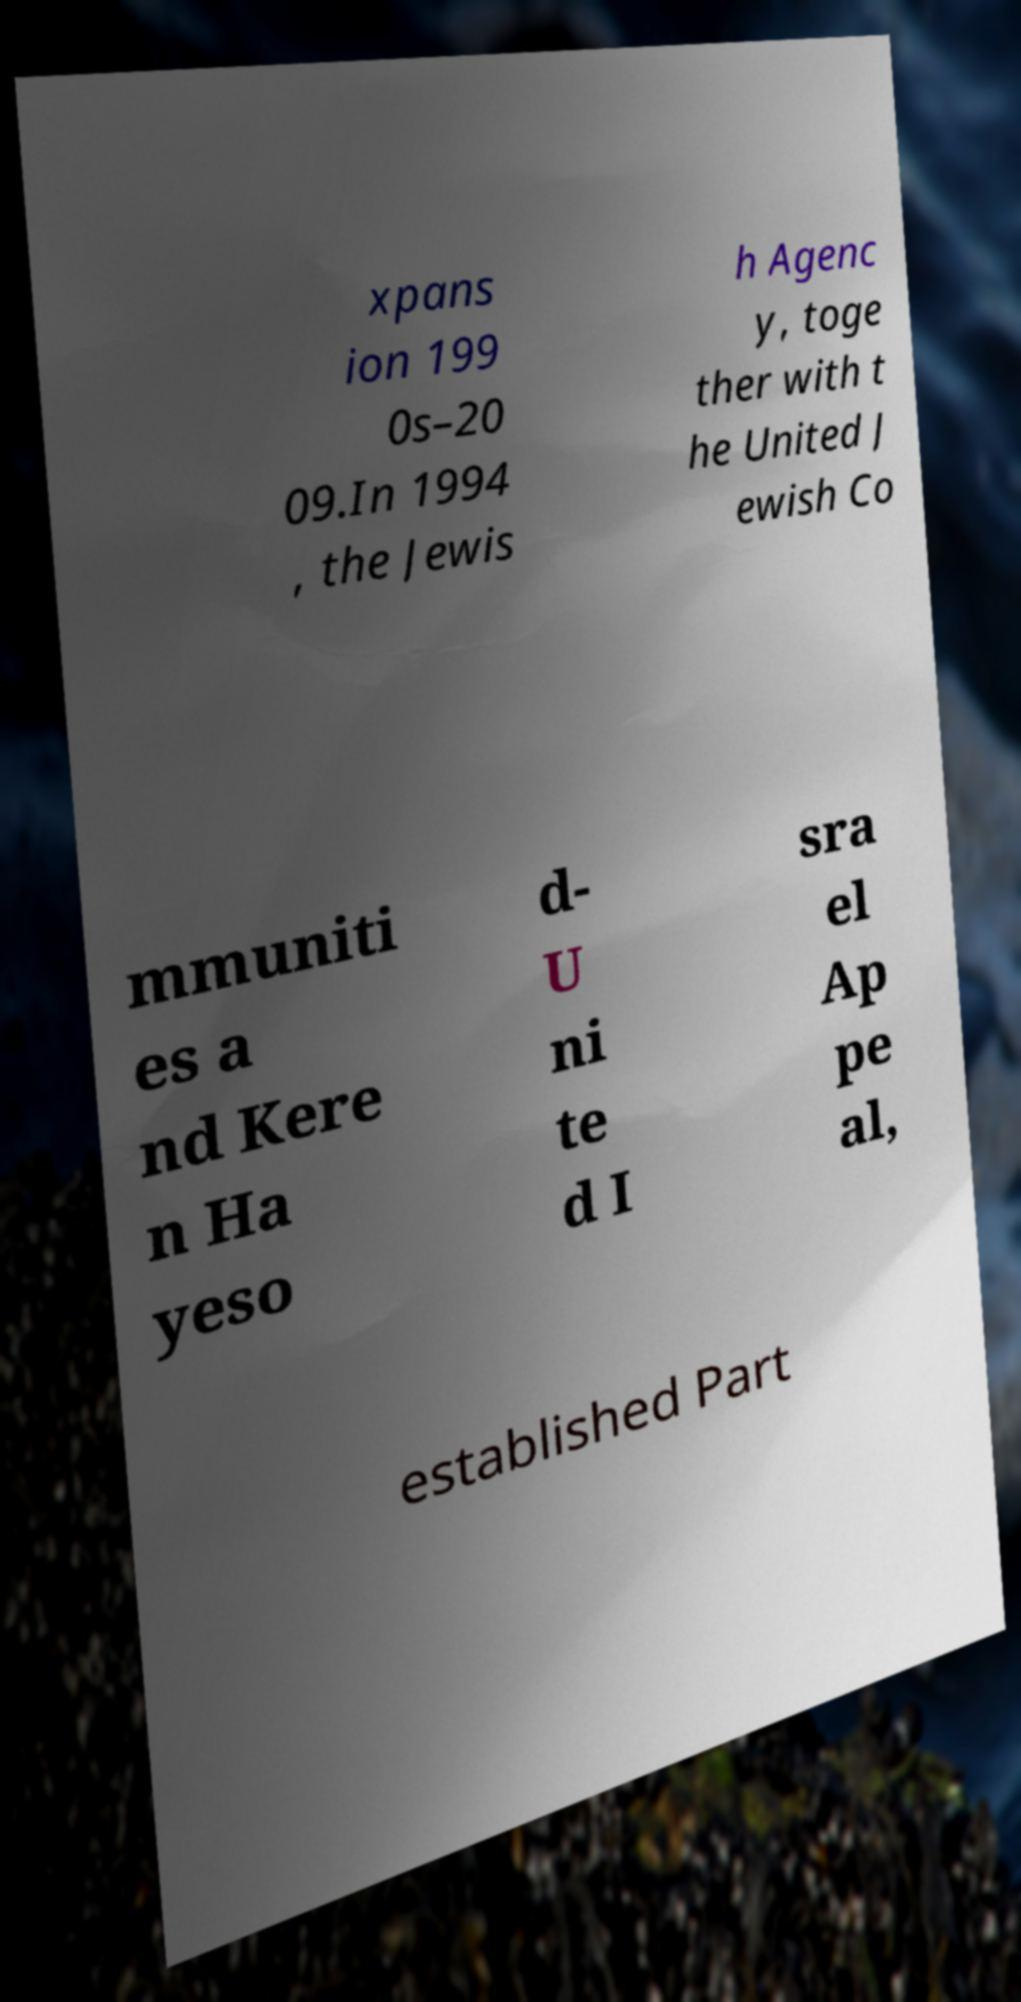Could you assist in decoding the text presented in this image and type it out clearly? xpans ion 199 0s–20 09.In 1994 , the Jewis h Agenc y, toge ther with t he United J ewish Co mmuniti es a nd Kere n Ha yeso d- U ni te d I sra el Ap pe al, established Part 